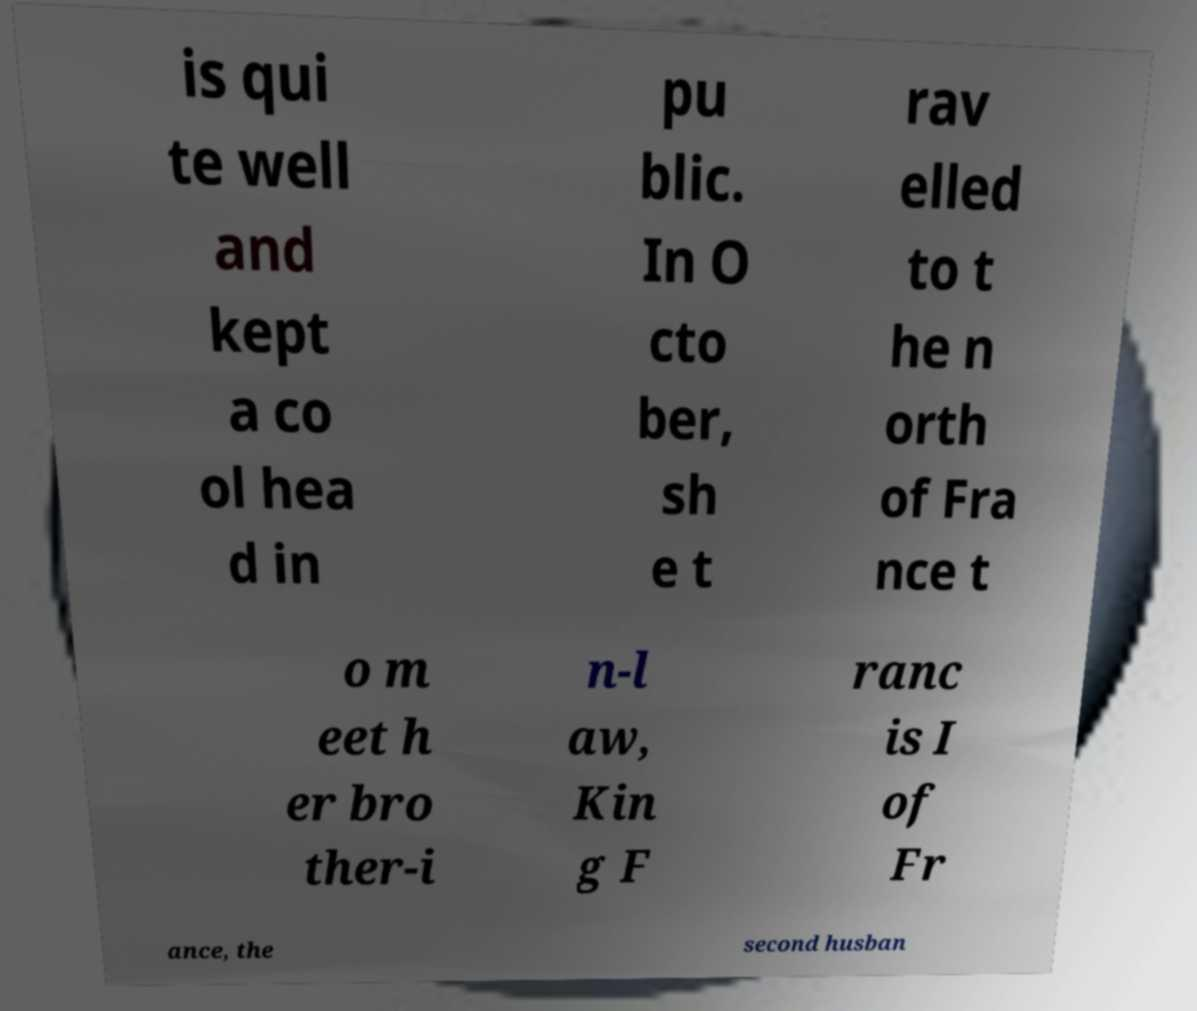Could you extract and type out the text from this image? is qui te well and kept a co ol hea d in pu blic. In O cto ber, sh e t rav elled to t he n orth of Fra nce t o m eet h er bro ther-i n-l aw, Kin g F ranc is I of Fr ance, the second husban 